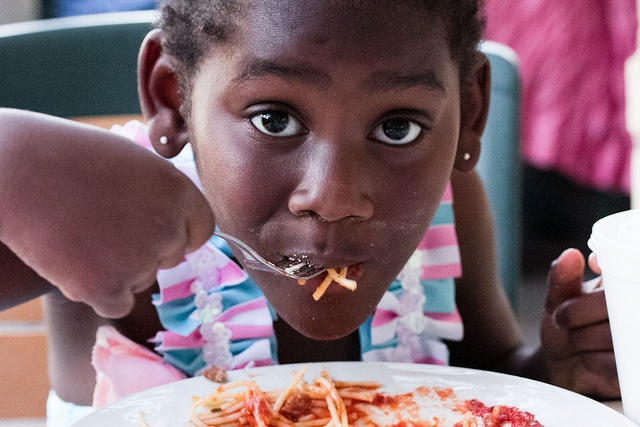Describe the objects in this image and their specific colors. I can see people in darkgray, maroon, black, and brown tones, chair in darkgray, purple, black, darkblue, and gray tones, cup in darkgray, white, black, and gray tones, and fork in darkgray, gray, and black tones in this image. 